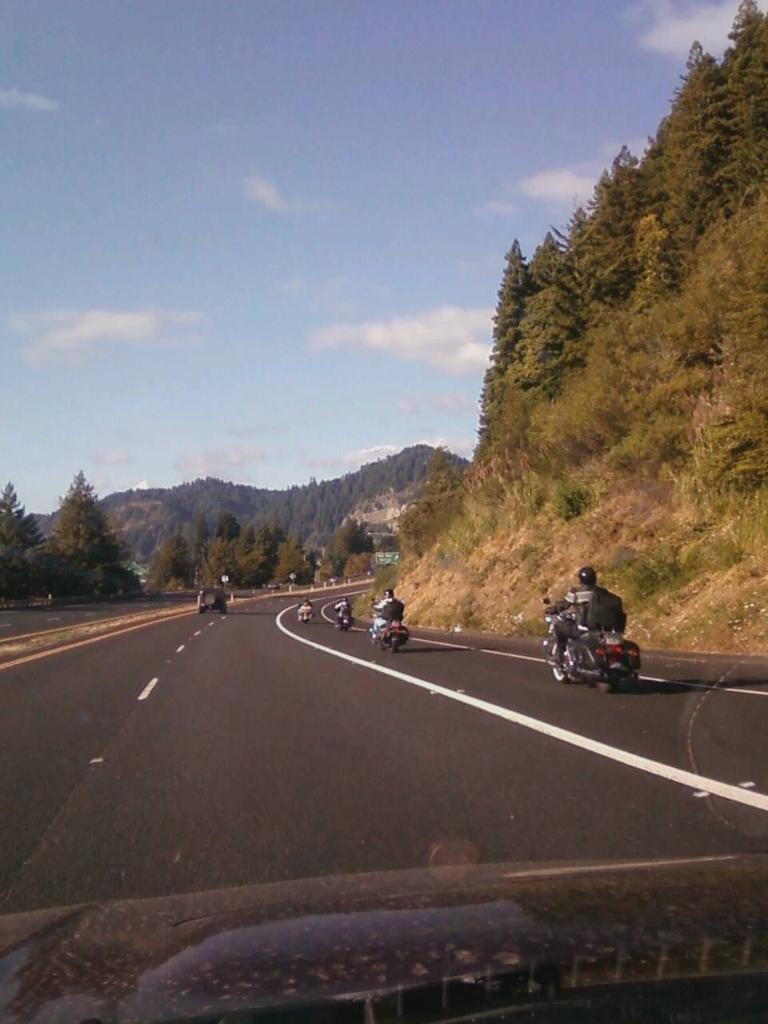What are the persons in the image doing? The persons in the image are riding motorbikes. Where are the motorbikes located? The motorbikes are on a road. What can be seen in the distance in the image? There are trees and a mountain visible in the distance. Can you tell me how many times the person on the motorbike swims across the river in the image? There is no river or swimming activity present in the image. What type of detail can be seen on the scarf worn by the person on the motorbike in the image? There is no scarf visible on any of the persons in the image. 